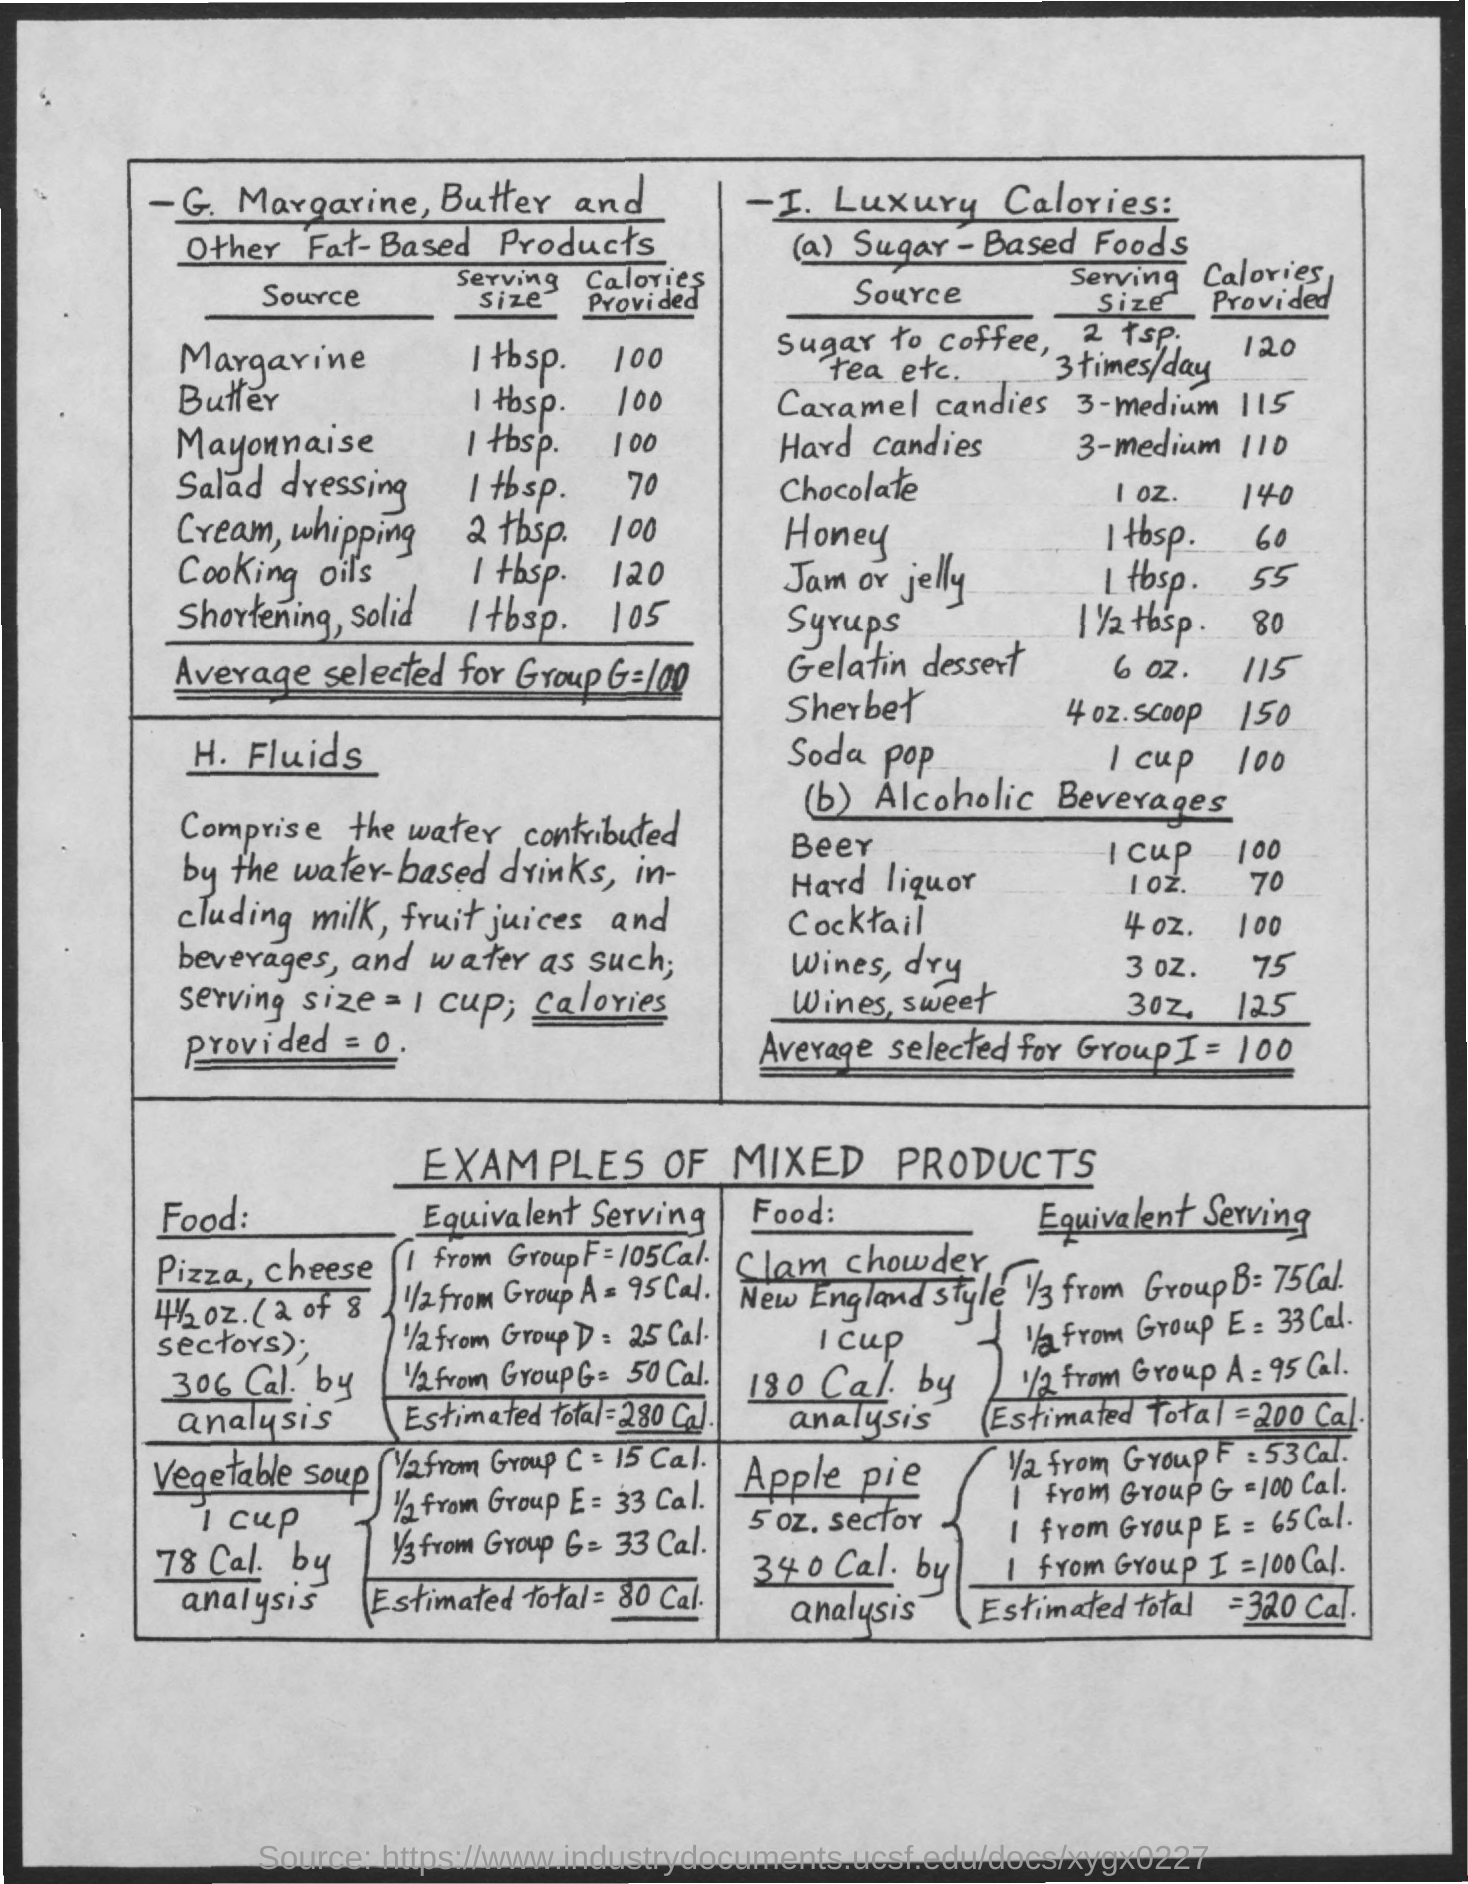How many Calories does 1 tbsp of Margarine provide?
Keep it short and to the point. 100. How many Calories does 1 tbsp of Butter provide?
Provide a succinct answer. 100. How many Calories does 1 tbsp of Mayonnaise provide?
Give a very brief answer. 100. How many Calories does 1 tbsp of Salad Dressing provide?
Offer a very short reply. 70. How many Calories does 2 tbsp of Cream, Whipping provide?
Give a very brief answer. 100. How many Calories does 1 tbsp of cooking Oils provide?
Offer a very short reply. 120. How many Calories does 1 tbsp of Shortening, solid provide?
Your answer should be compact. 105. What is the Average selected for Group G?
Make the answer very short. 100. What is the Average selected for Group I?
Offer a very short reply. 100. How many Calories does 2 tsp of sugar to coffee, tea etc provide?
Your answer should be very brief. 120. 